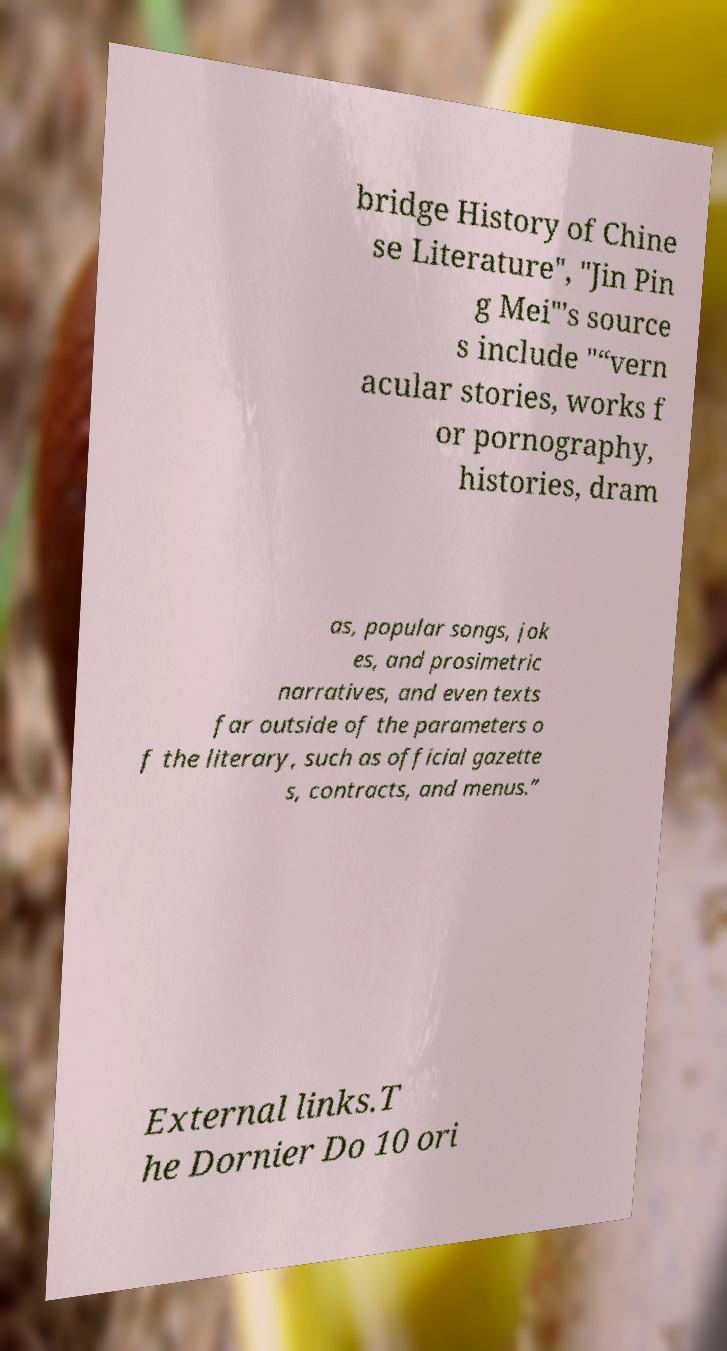Can you accurately transcribe the text from the provided image for me? bridge History of Chine se Literature", "Jin Pin g Mei"'s source s include "“vern acular stories, works f or pornography, histories, dram as, popular songs, jok es, and prosimetric narratives, and even texts far outside of the parameters o f the literary, such as official gazette s, contracts, and menus.” External links.T he Dornier Do 10 ori 